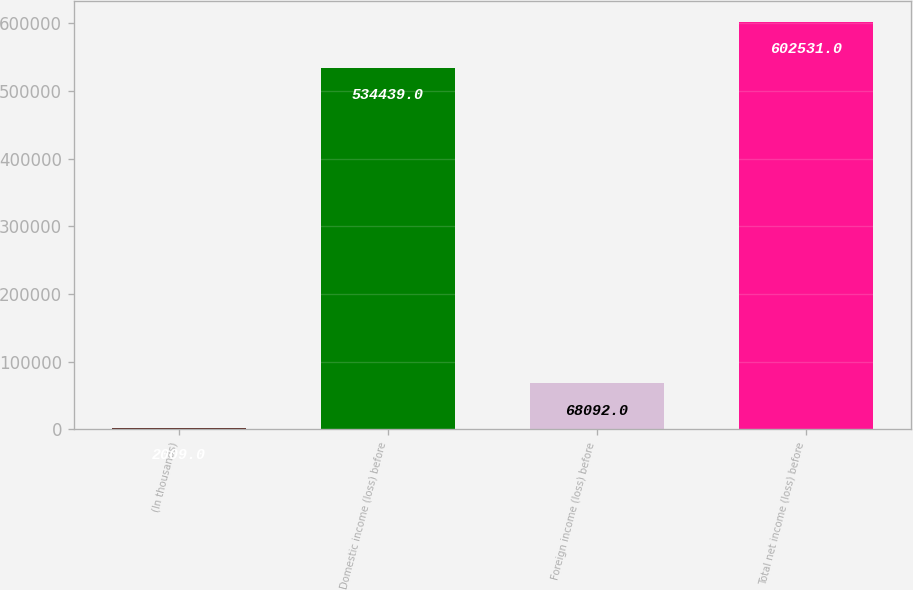Convert chart. <chart><loc_0><loc_0><loc_500><loc_500><bar_chart><fcel>(In thousands)<fcel>Domestic income (loss) before<fcel>Foreign income (loss) before<fcel>Total net income (loss) before<nl><fcel>2009<fcel>534439<fcel>68092<fcel>602531<nl></chart> 